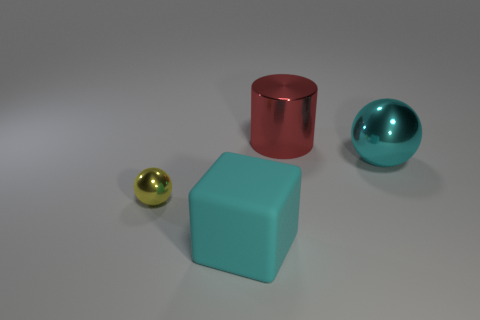Is there anything else that is the same shape as the cyan matte thing?
Keep it short and to the point. No. Is there any other thing that is the same material as the big cyan cube?
Ensure brevity in your answer.  No. There is a metallic thing that is the same color as the block; what is its size?
Keep it short and to the point. Large. Are there any other things that have the same size as the yellow object?
Provide a succinct answer. No. How many other things are there of the same color as the rubber object?
Keep it short and to the point. 1. What size is the object that is on the left side of the cylinder and on the right side of the yellow metallic thing?
Your answer should be compact. Large. What is the shape of the small yellow metallic object?
Keep it short and to the point. Sphere. There is a shiny thing that is in front of the cyan shiny ball; are there any tiny yellow balls in front of it?
Keep it short and to the point. No. What is the material of the block that is the same size as the red shiny thing?
Offer a very short reply. Rubber. Are there any cyan matte cylinders of the same size as the cyan shiny thing?
Provide a short and direct response. No. 